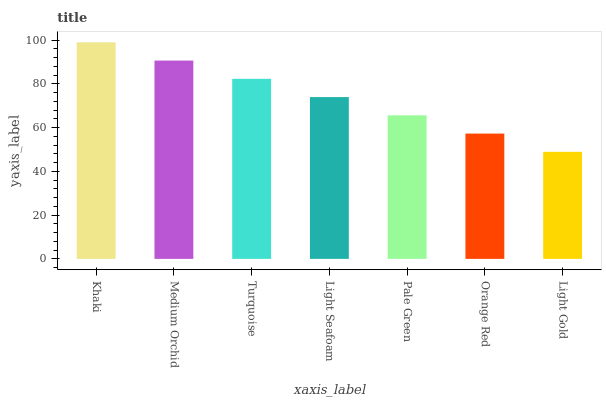Is Light Gold the minimum?
Answer yes or no. Yes. Is Khaki the maximum?
Answer yes or no. Yes. Is Medium Orchid the minimum?
Answer yes or no. No. Is Medium Orchid the maximum?
Answer yes or no. No. Is Khaki greater than Medium Orchid?
Answer yes or no. Yes. Is Medium Orchid less than Khaki?
Answer yes or no. Yes. Is Medium Orchid greater than Khaki?
Answer yes or no. No. Is Khaki less than Medium Orchid?
Answer yes or no. No. Is Light Seafoam the high median?
Answer yes or no. Yes. Is Light Seafoam the low median?
Answer yes or no. Yes. Is Medium Orchid the high median?
Answer yes or no. No. Is Orange Red the low median?
Answer yes or no. No. 